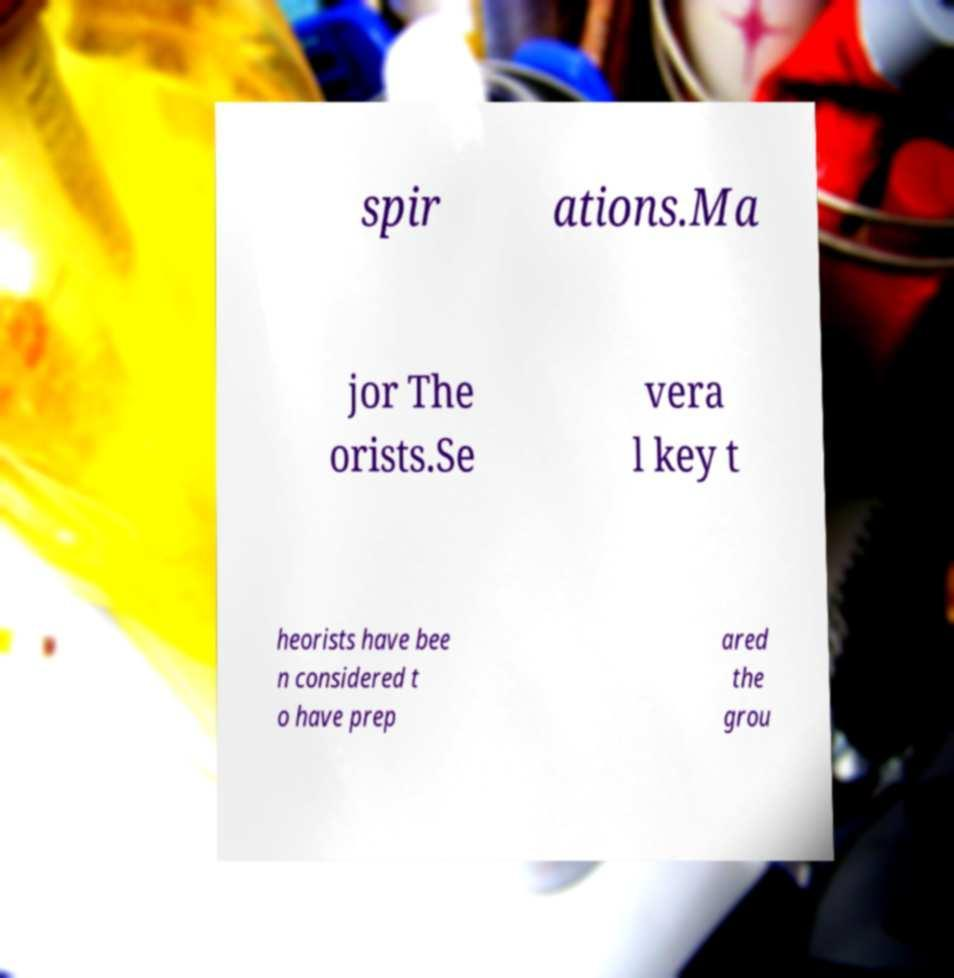Can you accurately transcribe the text from the provided image for me? spir ations.Ma jor The orists.Se vera l key t heorists have bee n considered t o have prep ared the grou 